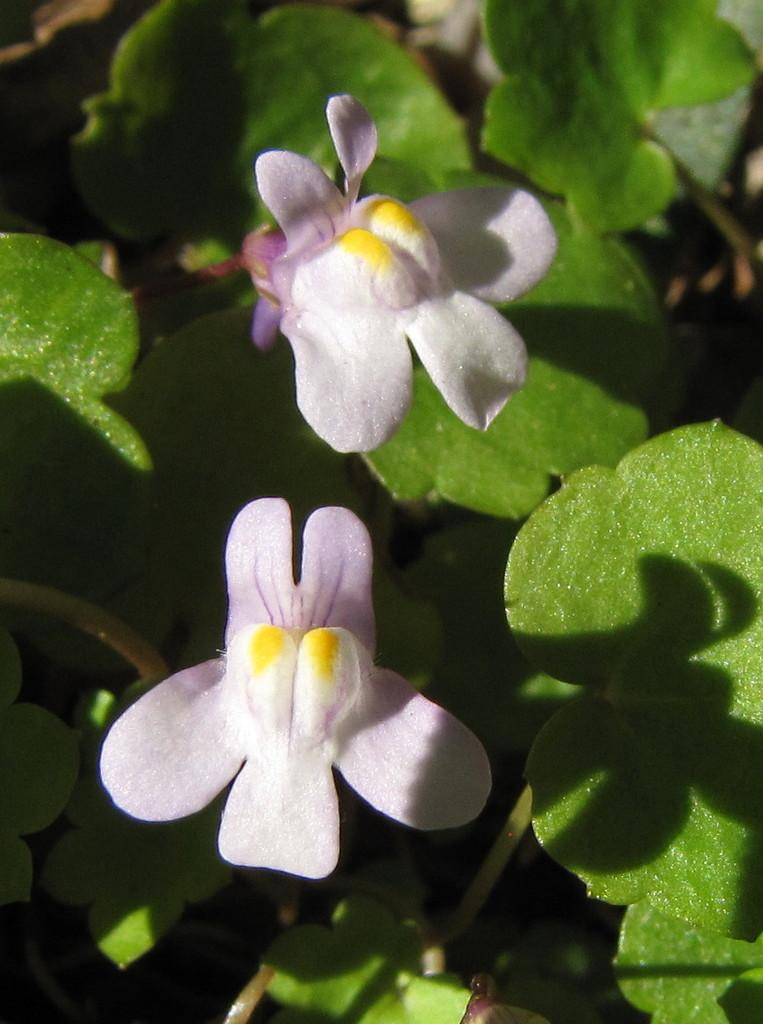What is present in the image? There is a plant in the image. How many flowers are on the plant? The plant has two flowers. What color are the flowers? The flowers are white in color. How does the plant express its emotions through crying in the image? Plants do not have the ability to express emotions or cry, so this is not present in the image. 